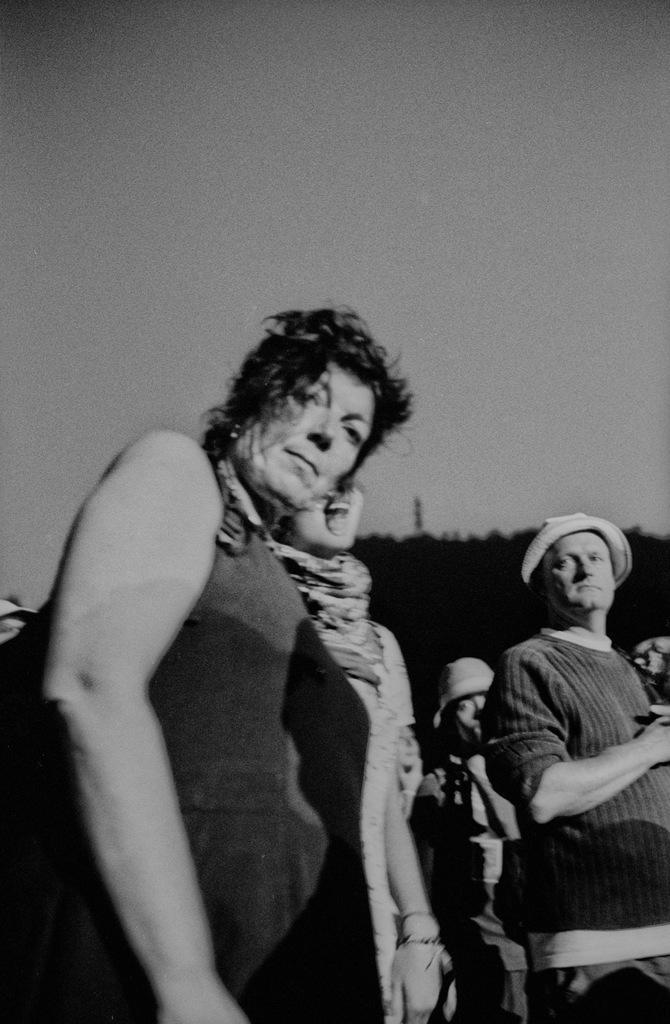In one or two sentences, can you explain what this image depicts? In this picture I can observe a woman on the left side. On the right side there are some people standing. Two of them are wearing hats on their heads. In the background there is sky. This is a black and white image. 